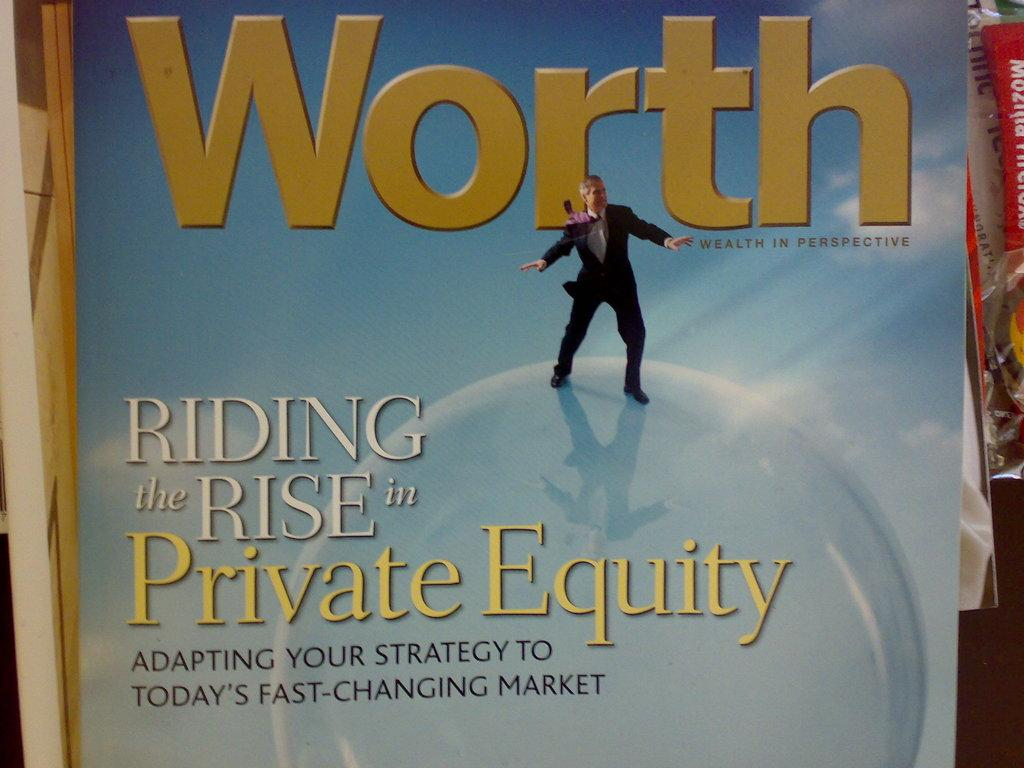What is featured on the poster in the image? The poster has a picture of a person and some text. Can you describe the person depicted on the poster? The provided facts do not include a description of the person on the poster. What else is present in the image besides the poster? There is a packet on the right side of the image. How many fingers can be seen on the person depicted on the poster? There is no information about the person's fingers on the poster, as the provided facts only mention the presence of a person's picture and some text. Are there any flies visible in the image? There is no mention of flies in the provided facts, so it cannot be determined if any are present in the image. 